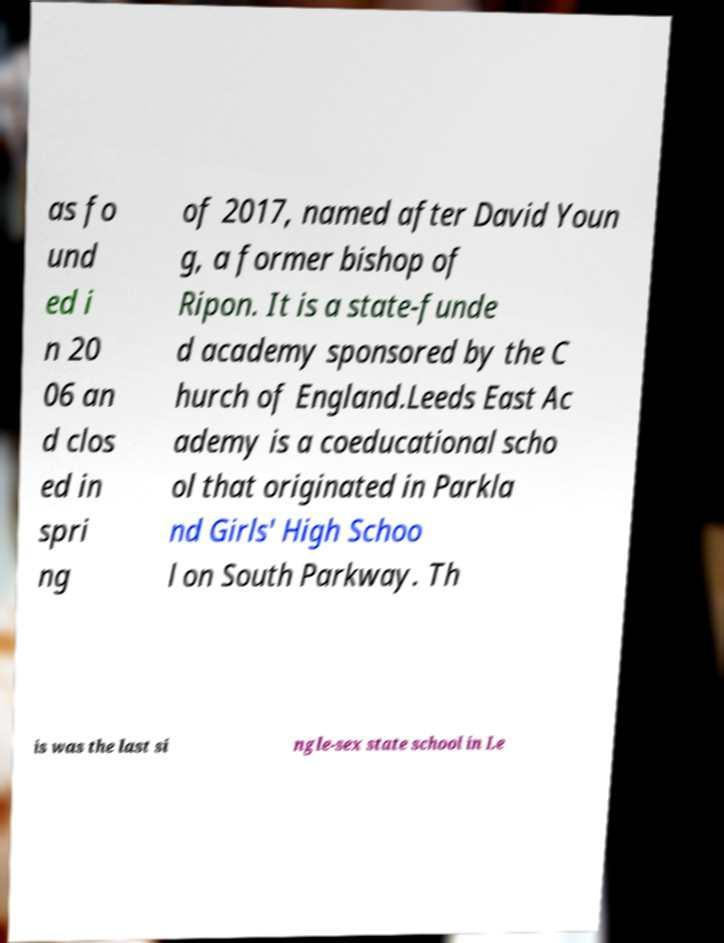Please read and relay the text visible in this image. What does it say? as fo und ed i n 20 06 an d clos ed in spri ng of 2017, named after David Youn g, a former bishop of Ripon. It is a state-funde d academy sponsored by the C hurch of England.Leeds East Ac ademy is a coeducational scho ol that originated in Parkla nd Girls' High Schoo l on South Parkway. Th is was the last si ngle-sex state school in Le 